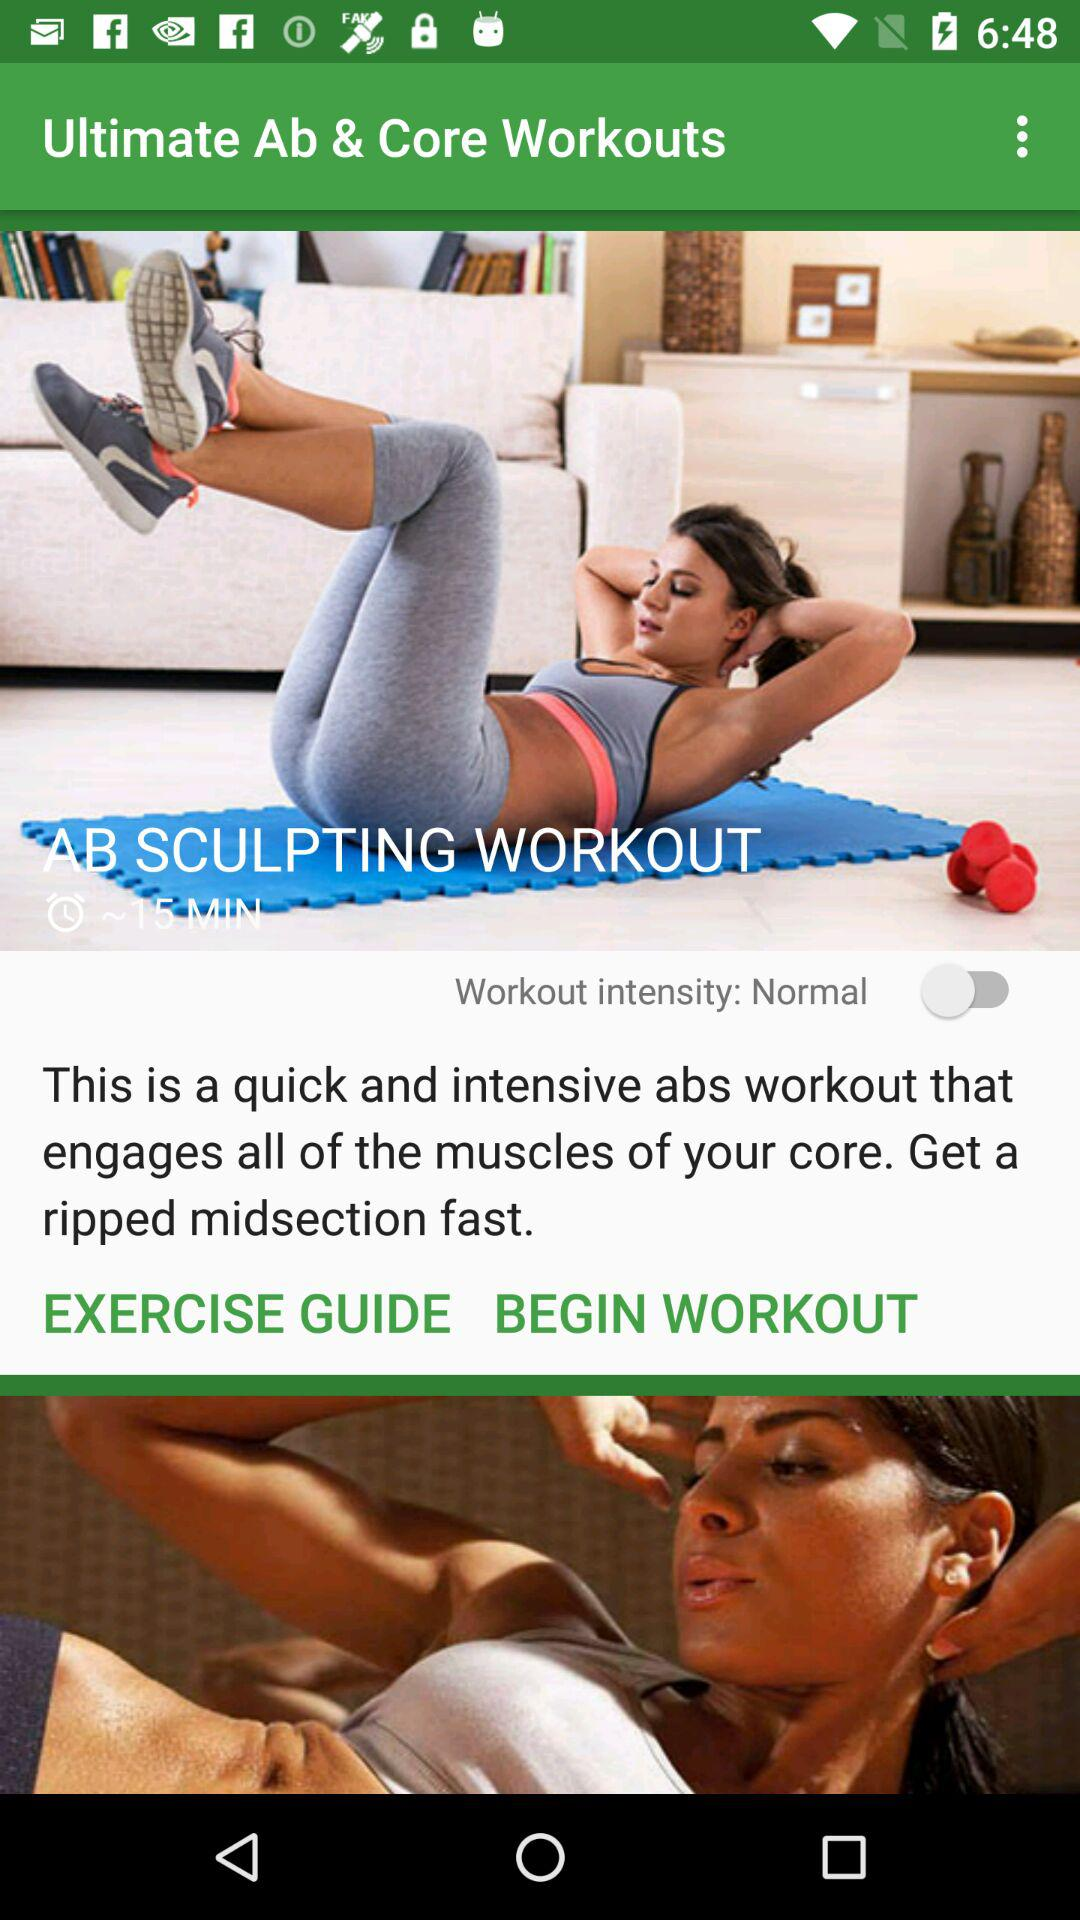How much is the time for an AB Sculpting workout? The AB Sculpting workout time is ~15 minutes. 